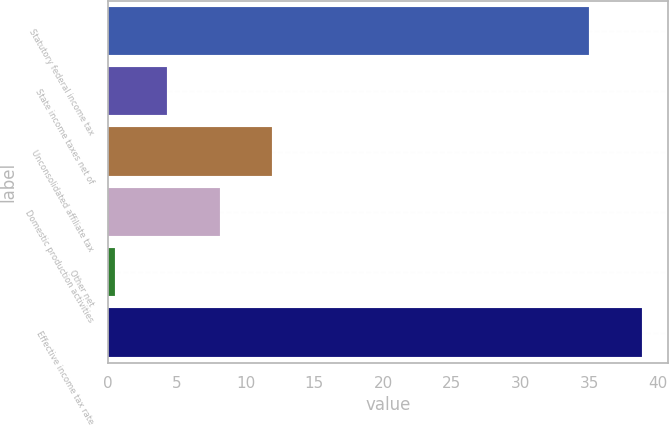<chart> <loc_0><loc_0><loc_500><loc_500><bar_chart><fcel>Statutory federal income tax<fcel>State income taxes net of<fcel>Unconsolidated affiliate tax<fcel>Domestic production activities<fcel>Other net<fcel>Effective income tax rate<nl><fcel>35<fcel>4.31<fcel>11.93<fcel>8.12<fcel>0.5<fcel>38.81<nl></chart> 